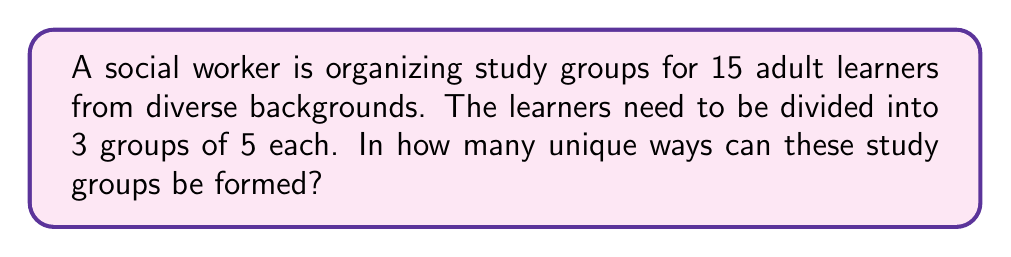Can you solve this math problem? Let's approach this step-by-step:

1) This is a partition problem, where we need to divide 15 people into 3 indistinguishable groups of 5 each.

2) We can solve this using the concept of combinations and the multiplication principle.

3) First, let's choose 5 people for the first group:
   $${15 \choose 5}$$

4) For the second group, we choose 5 from the remaining 10:
   $${10 \choose 5}$$

5) The last 5 automatically form the third group.

6) Multiplying these together gives us:
   $${15 \choose 5} \times {10 \choose 5}$$

7) However, this counts each arrangement multiple times because the order of selecting the groups doesn't matter.

8) We need to divide by the number of ways to arrange 3 groups, which is 3! = 6.

9) Therefore, the final formula is:
   $$\frac{{15 \choose 5} \times {10 \choose 5}}{3!}$$

10) Let's calculate:
    $${15 \choose 5} = 3003$$
    $${10 \choose 5} = 252$$
    
    $$\frac{3003 \times 252}{6} = 126,126$$

This approach ensures that each unique combination of groups is counted only once, accounting for the indistinguishability of the groups.
Answer: 126,126 